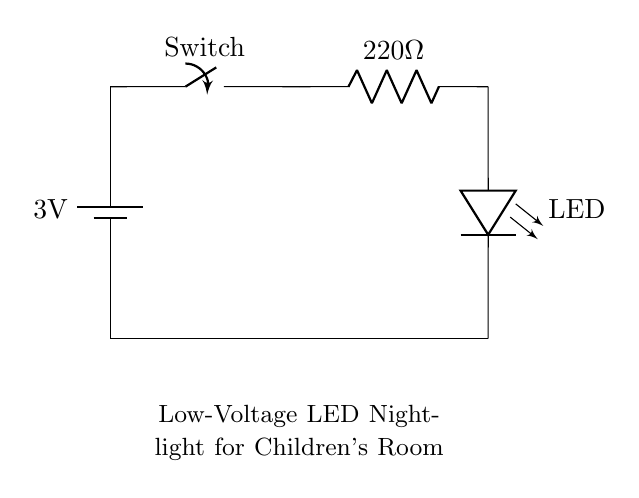What is the voltage of this circuit? The voltage is 3 volts, as indicated by the label on the battery symbol in the circuit diagram.
Answer: 3 volts What is the value of the resistor used in this circuit? The resistor has a value of 220 ohms, as indicated by the label next to the resistor symbol in the circuit diagram.
Answer: 220 ohms What component indicates the light source in this circuit? The component representing the light source is the LED, which is labeled accordingly in the diagram and has a specific symbol for an LED.
Answer: LED How does the switch affect the circuit? The switch controls the flow of current in the circuit; when open, it interrupts the current path, and when closed, it allows current to flow.
Answer: It controls current flow What is the purpose of using a resistor in this circuit? The resistor limits the current passing through the LED to prevent it from getting damaged by excessive current, ensuring safe operation.
Answer: To limit current What happens if a higher voltage battery is used? If a higher voltage battery is used, the LED may draw more current than it can handle, which could lead to overheating and failure, potentially damaging the LED.
Answer: It may damage the LED How is the circuit grounded? The circuit is grounded by connecting one side of the battery to the ground through the common negative terminal, which completes the circuit path.
Answer: Through the battery 